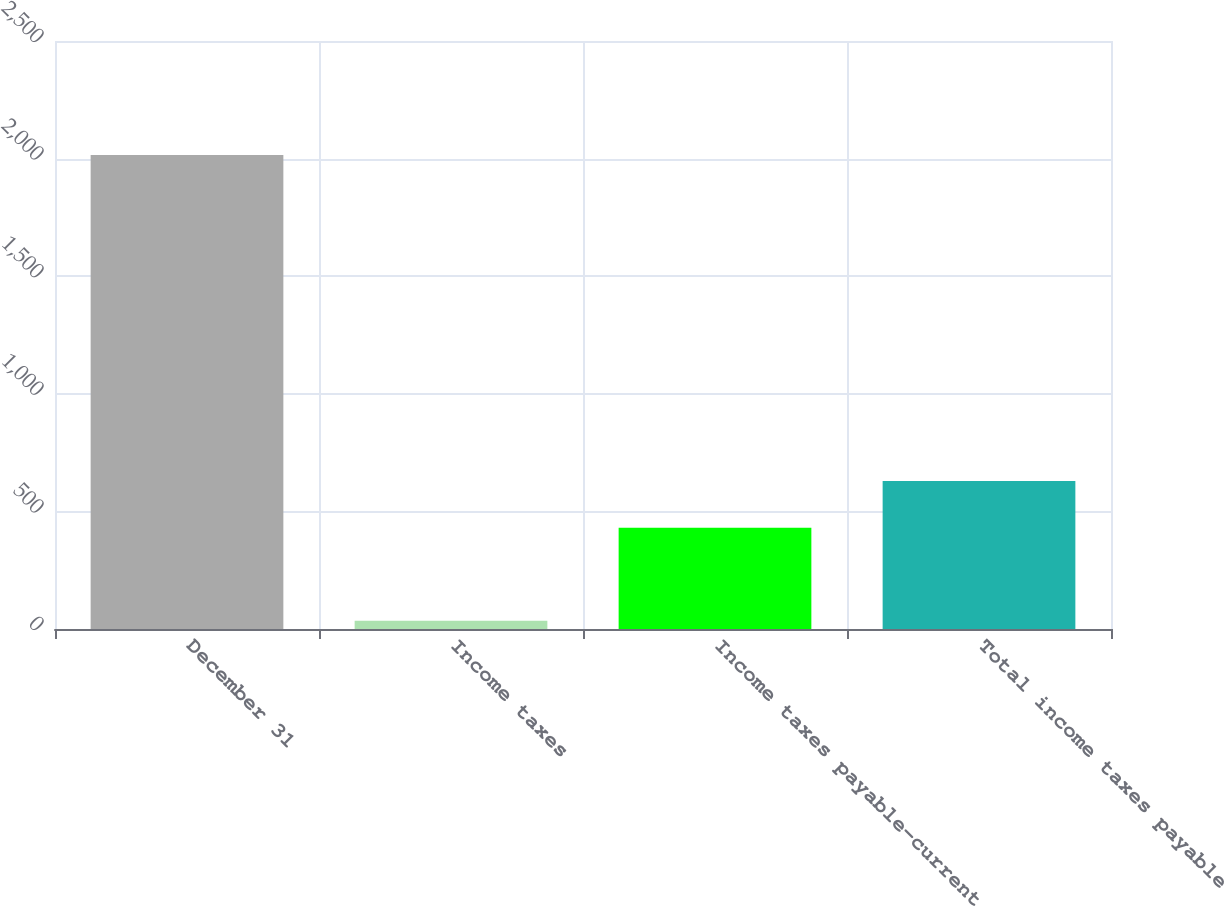<chart> <loc_0><loc_0><loc_500><loc_500><bar_chart><fcel>December 31<fcel>Income taxes<fcel>Income taxes payable-current<fcel>Total income taxes payable<nl><fcel>2015<fcel>35<fcel>431<fcel>629<nl></chart> 